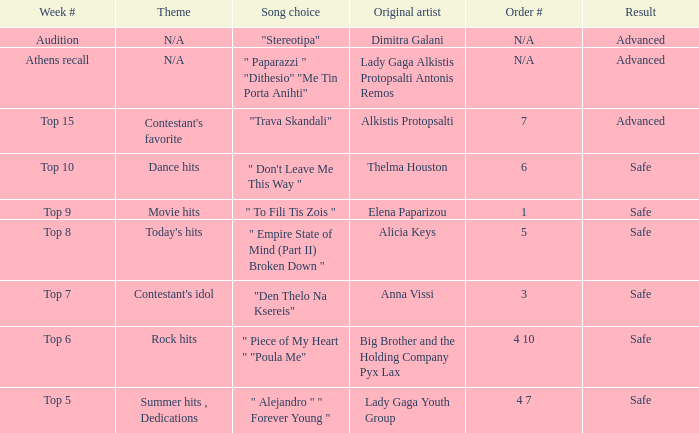Which week had the song choice " empire state of mind (part ii) broken down "? Top 8. 